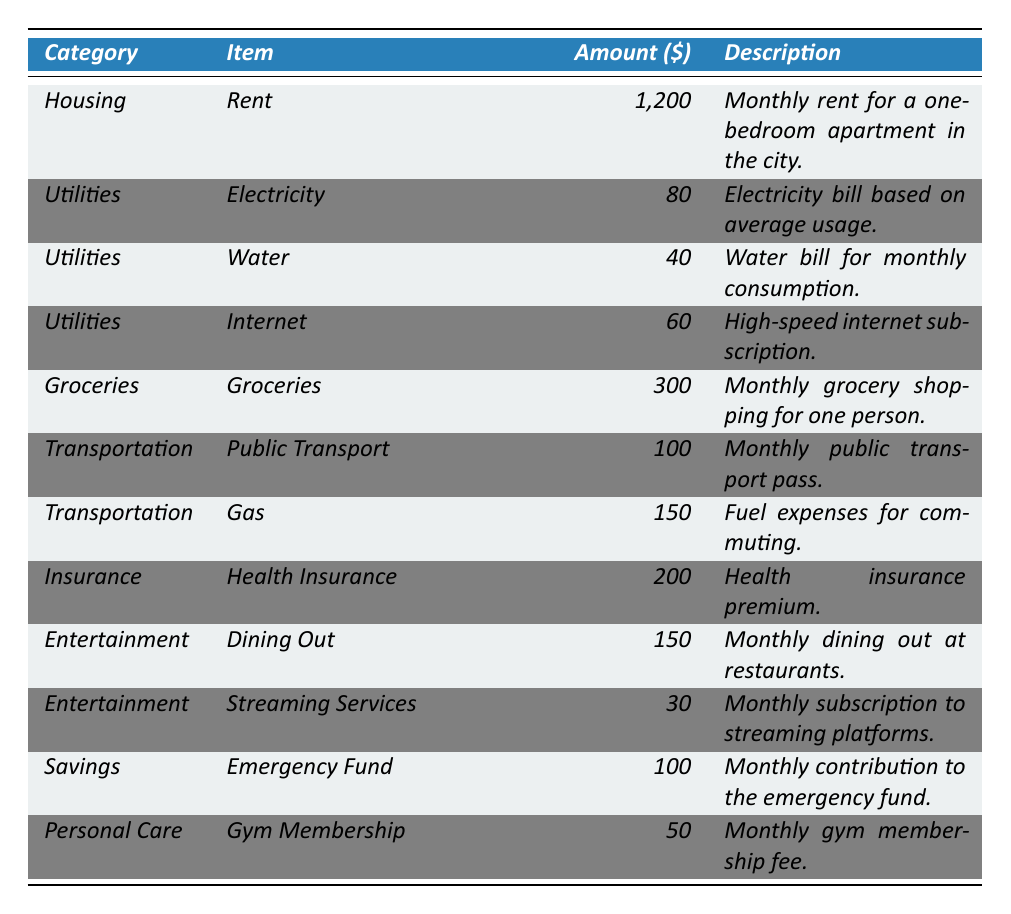What is the total amount spent on utilities? To find the total amount spent on utilities, add the amounts of Electricity ($80), Water ($40), and Internet ($60): 80 + 40 + 60 = 180.
Answer: 180 How much is spent on transportation? The transportation expenses include Public Transport ($100) and Gas ($150). Adding these amounts gives: 100 + 150 = 250.
Answer: 250 Is the health insurance premium higher than the monthly contribution to the emergency fund? Health Insurance costs $200 and the emergency fund contribution is $100. Since 200 > 100, the answer is yes.
Answer: Yes What is the cheapest item listed in the expenses? The item with the lowest cost is Water, which is $40.
Answer: $40 What is the total spending on groceries and dining out? Groceries cost $300 and Dining Out costs $150. Adding these amounts: 300 + 150 = 450.
Answer: 450 How much more is spent on rent compared to gym membership? Rent is $1200 and Gym Membership is $50. The difference is: 1200 - 50 = 1150.
Answer: 1150 Are the total amounts spent on entertainment greater than the total amount spent on personal care? The total entertainment expenses (Dining Out $150 + Streaming Services $30 = $180) is compared with personal care ($50). Since 180 > 50, the answer is yes.
Answer: Yes What category has the highest expense amount? The category with the highest expense amount is Housing with Rent at $1200.
Answer: Housing What is the average amount spent on utilities? The total for utilities is $180 (from the previous question). There are three utility items, so the average is: 180 / 3 = 60.
Answer: 60 What is the total amount spent across all categories? Adding all the amounts together: 1200 (Housing) + 180 (Utilities) + 300 (Groceries) + 250 (Transportation) + 200 (Insurance) + 180 (Entertainment) + 100 (Savings) + 50 (Personal Care) gives a total of $2560.
Answer: 2560 